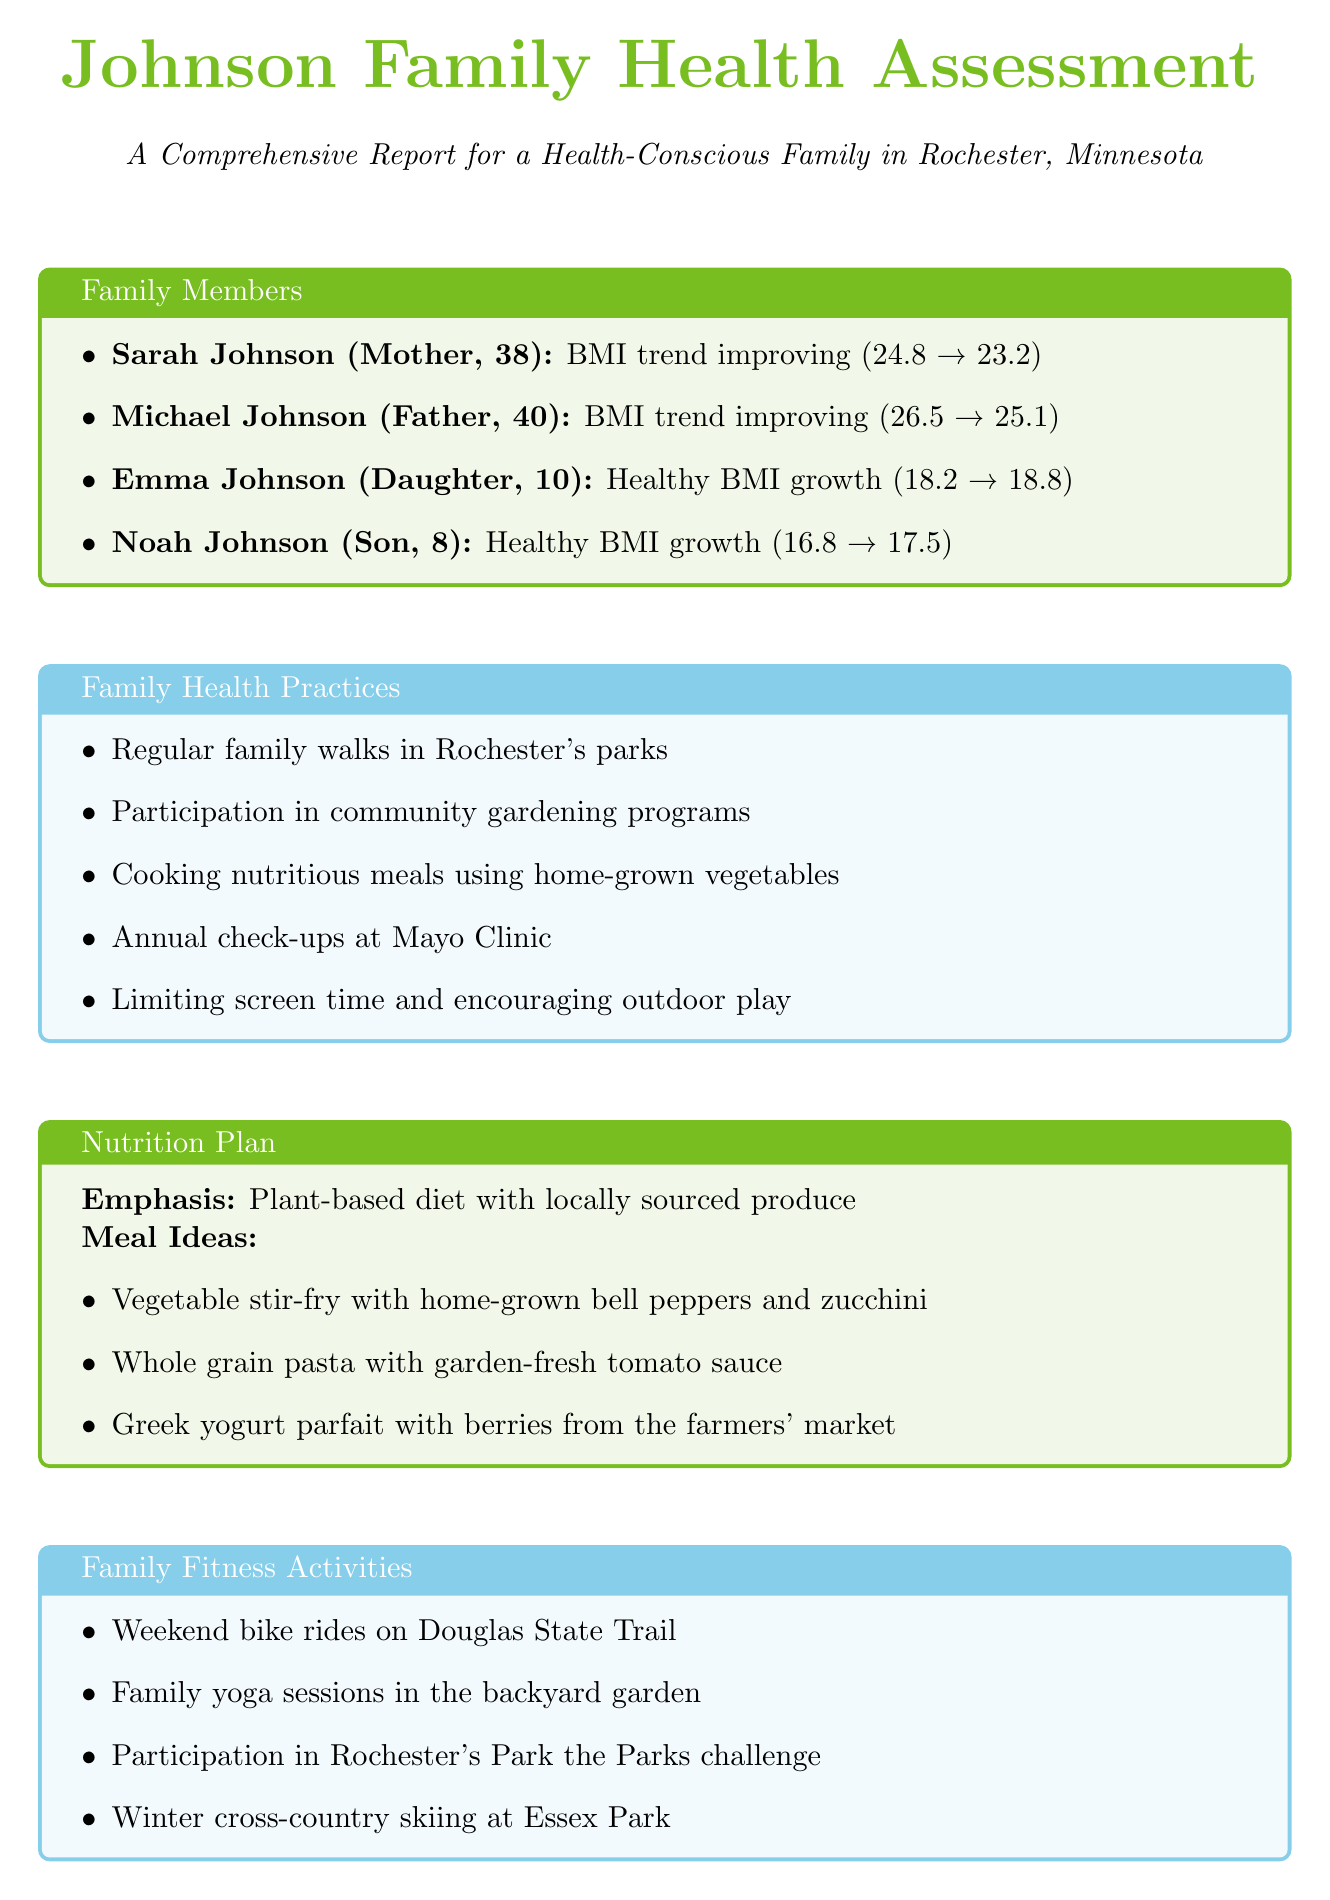What was Sarah Johnson's BMI in 2021? Sarah's BMI in 2021 is directly mentioned in the document under her BMI trend.
Answer: 24.8 What is Michael Johnson's fitness goal? Michael's fitness goal is stated explicitly in the document under his fitness goal.
Answer: Reduce BMI to healthy range and improve cardiovascular health Which family member had the highest BMI trend in 2023? By examining the BMI trends of all family members, Michael has the highest BMI in 2023, as described in the document.
Answer: Michael Johnson What are two family health practices mentioned in the report? The document lists several family health practices; any two can be mentioned as examples.
Answer: Regular family walks in Rochester's parks, cooking nutritious meals using home-grown vegetables What is the emphasis of the nutrition plan? The nutrition plan emphasizes a specific dietary approach, which is mentioned in the plan section.
Answer: Plant-based diet with locally sourced produce What activity does the family participate in during winter? The document describes a specific family fitness activity that is relevant to winter.
Answer: Winter cross-country skiing at Essex Park What is one benefit of gardening mentioned in the report? One of the garden health benefits is listed in the respective section of the document.
Answer: Access to fresh, organic produce How many years did Sarah Johnson's BMI improve? By analyzing the specified years in Sarah's BMI trend, we can determine the span of the trend improvement.
Answer: 2 years 